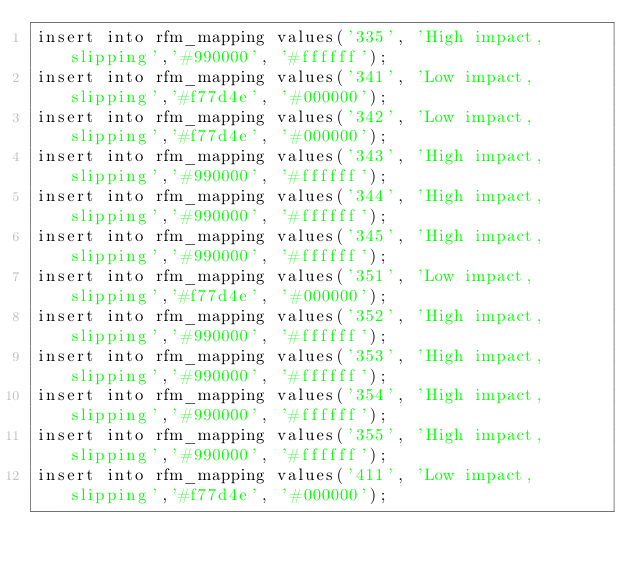Convert code to text. <code><loc_0><loc_0><loc_500><loc_500><_SQL_>insert into rfm_mapping values('335', 'High impact, slipping','#990000', '#ffffff');
insert into rfm_mapping values('341', 'Low impact, slipping','#f77d4e', '#000000');
insert into rfm_mapping values('342', 'Low impact, slipping','#f77d4e', '#000000');
insert into rfm_mapping values('343', 'High impact, slipping','#990000', '#ffffff');
insert into rfm_mapping values('344', 'High impact, slipping','#990000', '#ffffff');
insert into rfm_mapping values('345', 'High impact, slipping','#990000', '#ffffff');
insert into rfm_mapping values('351', 'Low impact, slipping','#f77d4e', '#000000');
insert into rfm_mapping values('352', 'High impact, slipping','#990000', '#ffffff');
insert into rfm_mapping values('353', 'High impact, slipping','#990000', '#ffffff');
insert into rfm_mapping values('354', 'High impact, slipping','#990000', '#ffffff');
insert into rfm_mapping values('355', 'High impact, slipping','#990000', '#ffffff');
insert into rfm_mapping values('411', 'Low impact, slipping','#f77d4e', '#000000');</code> 